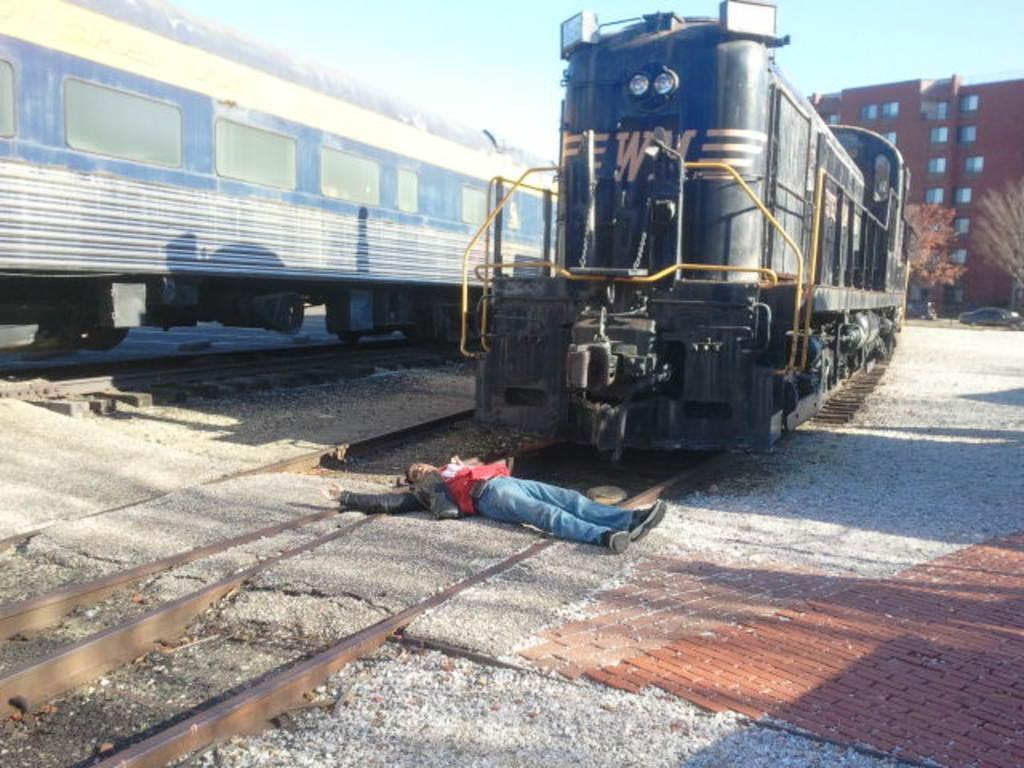In one or two sentences, can you explain what this image depicts? In this picture I can see there is a person lying on the train track and there is a train on to left side. There is another train on to right and in the backdrop there are vehicles moving and there are trees, buildings and sky is clear. 